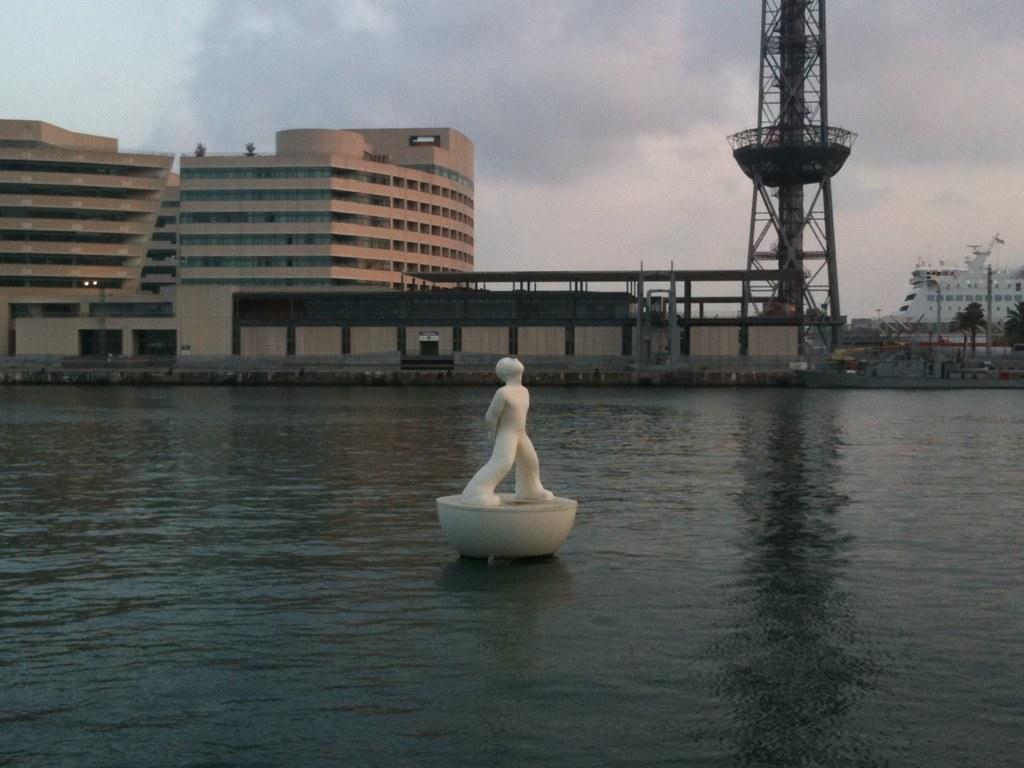How would you summarize this image in a sentence or two? In this image we can see the statue in the water. Here we can see the buildings, tower, trees, ship and the cloudy sky in the background. 